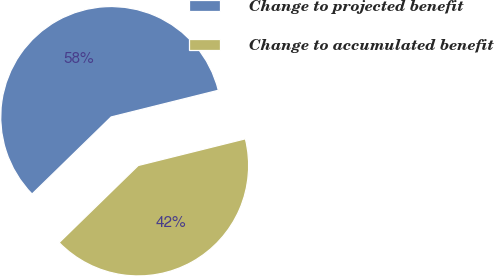<chart> <loc_0><loc_0><loc_500><loc_500><pie_chart><fcel>Change to projected benefit<fcel>Change to accumulated benefit<nl><fcel>58.41%<fcel>41.59%<nl></chart> 